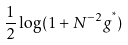<formula> <loc_0><loc_0><loc_500><loc_500>\frac { 1 } { 2 } \log ( 1 + N ^ { - 2 } g ^ { ^ { * } } )</formula> 